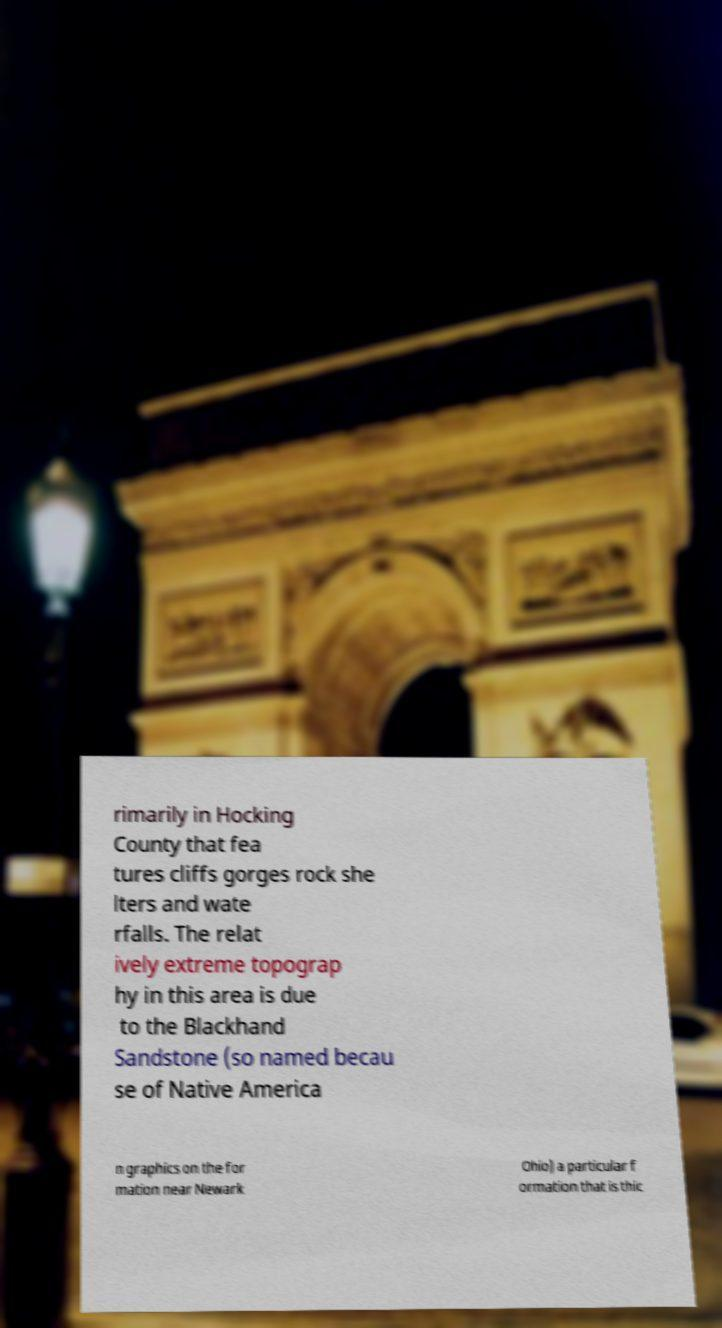Please read and relay the text visible in this image. What does it say? rimarily in Hocking County that fea tures cliffs gorges rock she lters and wate rfalls. The relat ively extreme topograp hy in this area is due to the Blackhand Sandstone (so named becau se of Native America n graphics on the for mation near Newark Ohio) a particular f ormation that is thic 